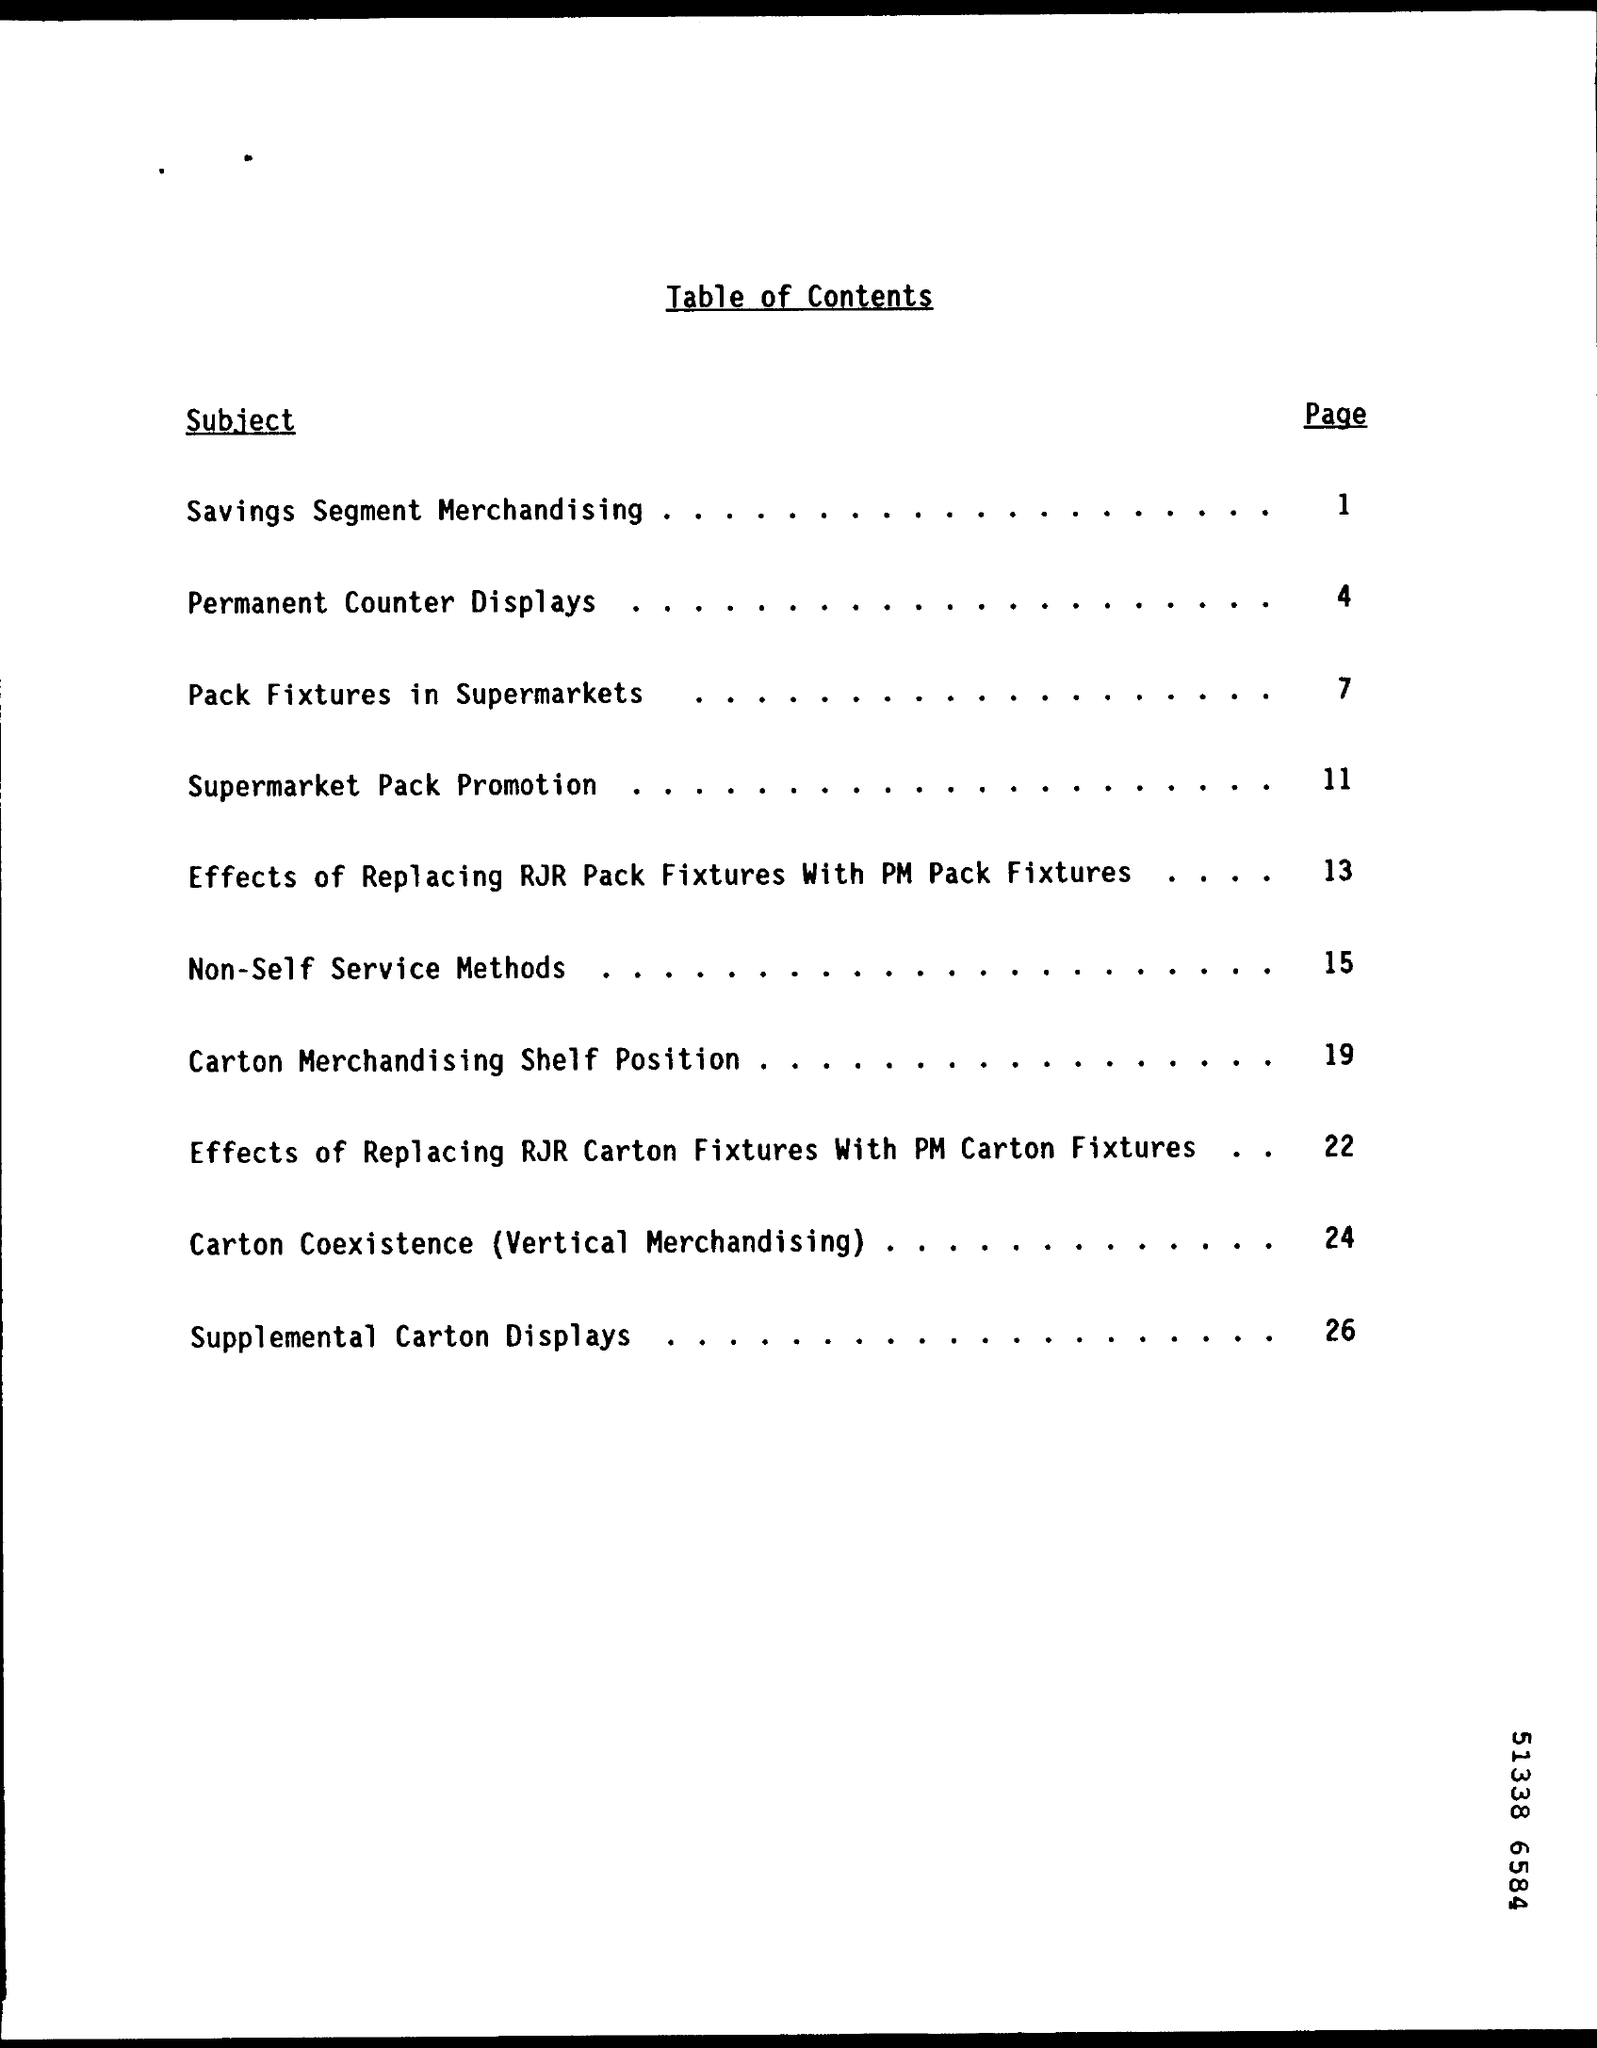What is the Title of the document?
Keep it short and to the point. Table of Contents. What is the Page Number for Subject "Savings Segment Merchandising"?
Your answer should be compact. 1. What is the Page Number for Subject "Permanent Counter Displays"?
Provide a short and direct response. 4. 